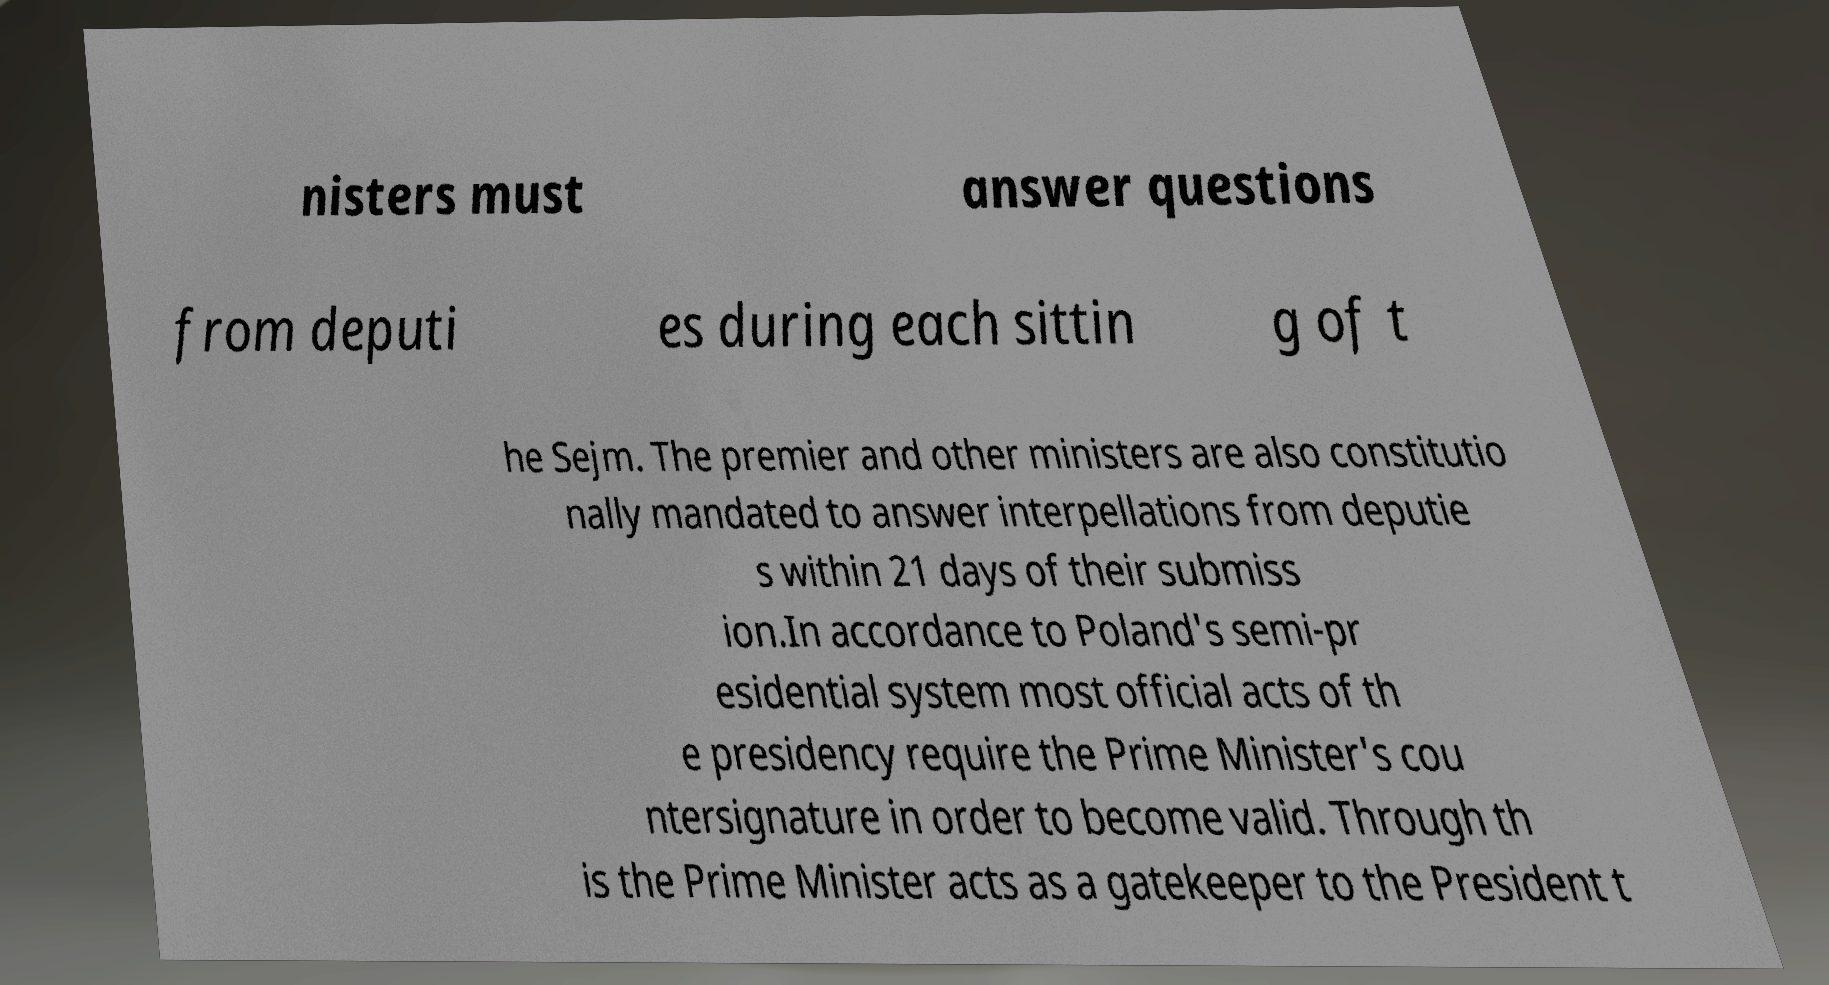Can you read and provide the text displayed in the image?This photo seems to have some interesting text. Can you extract and type it out for me? nisters must answer questions from deputi es during each sittin g of t he Sejm. The premier and other ministers are also constitutio nally mandated to answer interpellations from deputie s within 21 days of their submiss ion.In accordance to Poland's semi-pr esidential system most official acts of th e presidency require the Prime Minister's cou ntersignature in order to become valid. Through th is the Prime Minister acts as a gatekeeper to the President t 